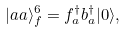Convert formula to latex. <formula><loc_0><loc_0><loc_500><loc_500>| a a \rangle _ { f } ^ { 6 } = f _ { a } ^ { \dagger } b _ { a } ^ { \dagger } | 0 \rangle ,</formula> 